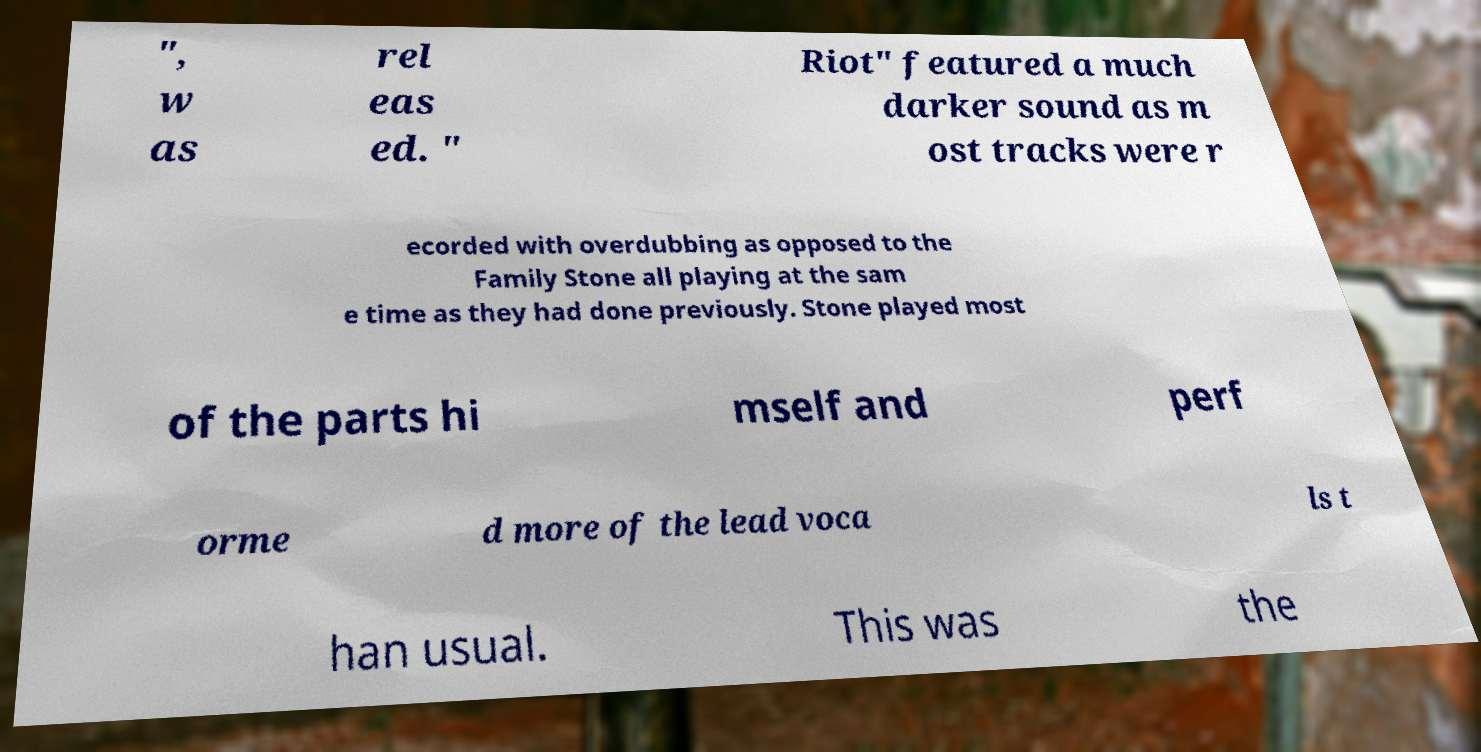For documentation purposes, I need the text within this image transcribed. Could you provide that? ", w as rel eas ed. " Riot" featured a much darker sound as m ost tracks were r ecorded with overdubbing as opposed to the Family Stone all playing at the sam e time as they had done previously. Stone played most of the parts hi mself and perf orme d more of the lead voca ls t han usual. This was the 